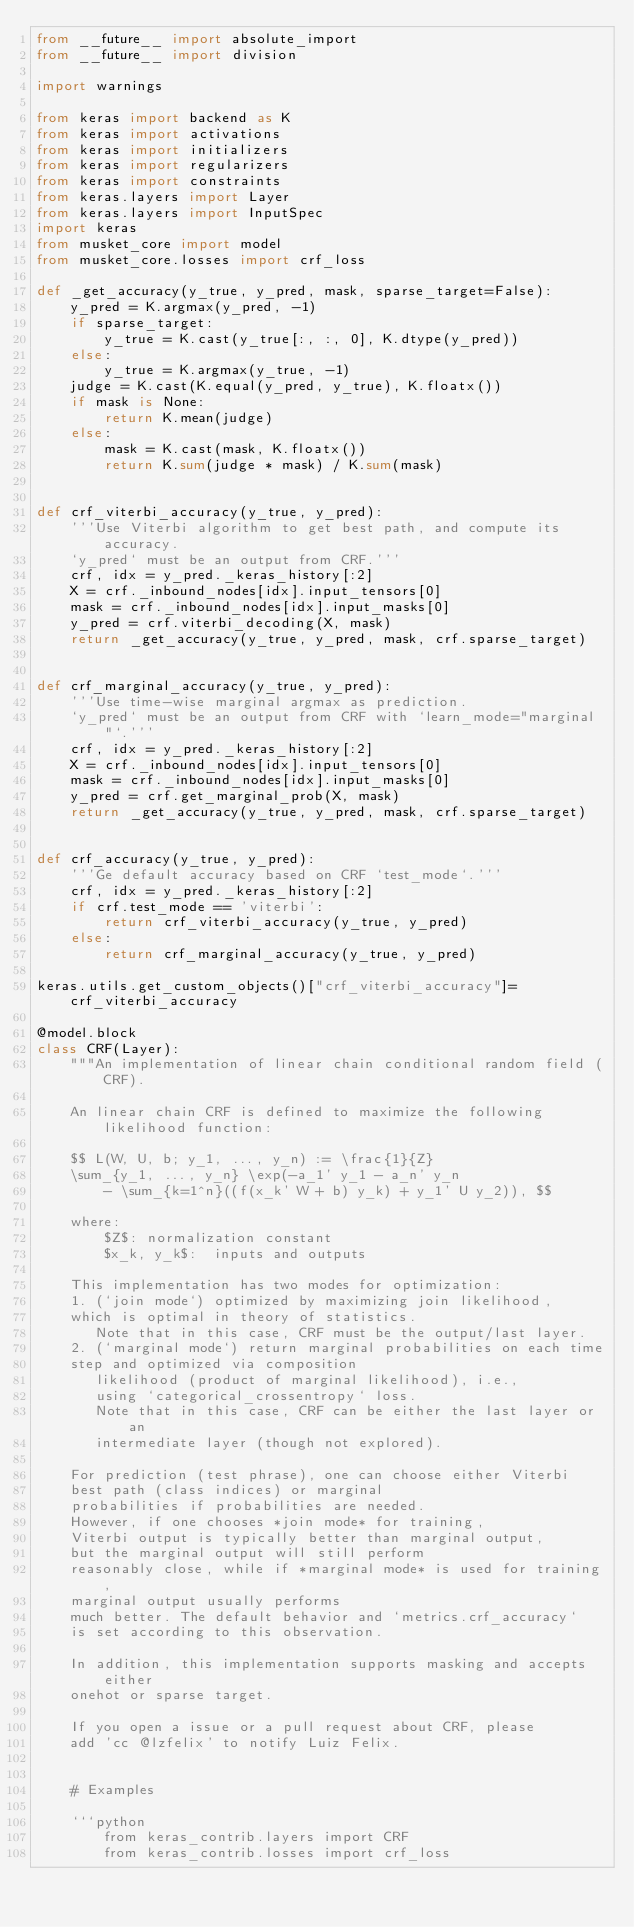Convert code to text. <code><loc_0><loc_0><loc_500><loc_500><_Python_>from __future__ import absolute_import
from __future__ import division

import warnings

from keras import backend as K
from keras import activations
from keras import initializers
from keras import regularizers
from keras import constraints
from keras.layers import Layer
from keras.layers import InputSpec
import keras
from musket_core import model
from musket_core.losses import crf_loss
        
def _get_accuracy(y_true, y_pred, mask, sparse_target=False):
    y_pred = K.argmax(y_pred, -1)
    if sparse_target:
        y_true = K.cast(y_true[:, :, 0], K.dtype(y_pred))
    else:
        y_true = K.argmax(y_true, -1)
    judge = K.cast(K.equal(y_pred, y_true), K.floatx())
    if mask is None:
        return K.mean(judge)
    else:
        mask = K.cast(mask, K.floatx())
        return K.sum(judge * mask) / K.sum(mask)


def crf_viterbi_accuracy(y_true, y_pred):
    '''Use Viterbi algorithm to get best path, and compute its accuracy.
    `y_pred` must be an output from CRF.'''
    crf, idx = y_pred._keras_history[:2]
    X = crf._inbound_nodes[idx].input_tensors[0]
    mask = crf._inbound_nodes[idx].input_masks[0]
    y_pred = crf.viterbi_decoding(X, mask)
    return _get_accuracy(y_true, y_pred, mask, crf.sparse_target)


def crf_marginal_accuracy(y_true, y_pred):
    '''Use time-wise marginal argmax as prediction.
    `y_pred` must be an output from CRF with `learn_mode="marginal"`.'''
    crf, idx = y_pred._keras_history[:2]
    X = crf._inbound_nodes[idx].input_tensors[0]
    mask = crf._inbound_nodes[idx].input_masks[0]
    y_pred = crf.get_marginal_prob(X, mask)
    return _get_accuracy(y_true, y_pred, mask, crf.sparse_target)


def crf_accuracy(y_true, y_pred):
    '''Ge default accuracy based on CRF `test_mode`.'''
    crf, idx = y_pred._keras_history[:2]
    if crf.test_mode == 'viterbi':
        return crf_viterbi_accuracy(y_true, y_pred)
    else:
        return crf_marginal_accuracy(y_true, y_pred)        

keras.utils.get_custom_objects()["crf_viterbi_accuracy"]=crf_viterbi_accuracy

@model.block
class CRF(Layer):
    """An implementation of linear chain conditional random field (CRF).

    An linear chain CRF is defined to maximize the following likelihood function:

    $$ L(W, U, b; y_1, ..., y_n) := \frac{1}{Z}
    \sum_{y_1, ..., y_n} \exp(-a_1' y_1 - a_n' y_n
        - \sum_{k=1^n}((f(x_k' W + b) y_k) + y_1' U y_2)), $$

    where:
        $Z$: normalization constant
        $x_k, y_k$:  inputs and outputs

    This implementation has two modes for optimization:
    1. (`join mode`) optimized by maximizing join likelihood,
    which is optimal in theory of statistics.
       Note that in this case, CRF must be the output/last layer.
    2. (`marginal mode`) return marginal probabilities on each time
    step and optimized via composition
       likelihood (product of marginal likelihood), i.e.,
       using `categorical_crossentropy` loss.
       Note that in this case, CRF can be either the last layer or an
       intermediate layer (though not explored).

    For prediction (test phrase), one can choose either Viterbi
    best path (class indices) or marginal
    probabilities if probabilities are needed.
    However, if one chooses *join mode* for training,
    Viterbi output is typically better than marginal output,
    but the marginal output will still perform
    reasonably close, while if *marginal mode* is used for training,
    marginal output usually performs
    much better. The default behavior and `metrics.crf_accuracy`
    is set according to this observation.

    In addition, this implementation supports masking and accepts either
    onehot or sparse target.

    If you open a issue or a pull request about CRF, please
    add 'cc @lzfelix' to notify Luiz Felix.


    # Examples

    ```python
        from keras_contrib.layers import CRF
        from keras_contrib.losses import crf_loss</code> 